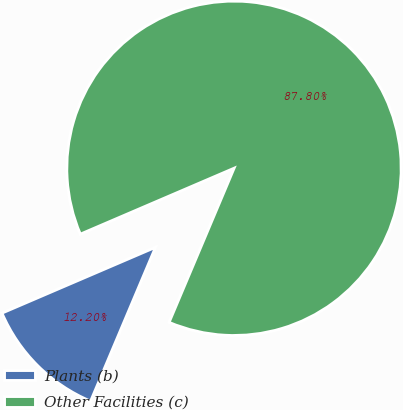<chart> <loc_0><loc_0><loc_500><loc_500><pie_chart><fcel>Plants (b)<fcel>Other Facilities (c)<nl><fcel>12.2%<fcel>87.8%<nl></chart> 